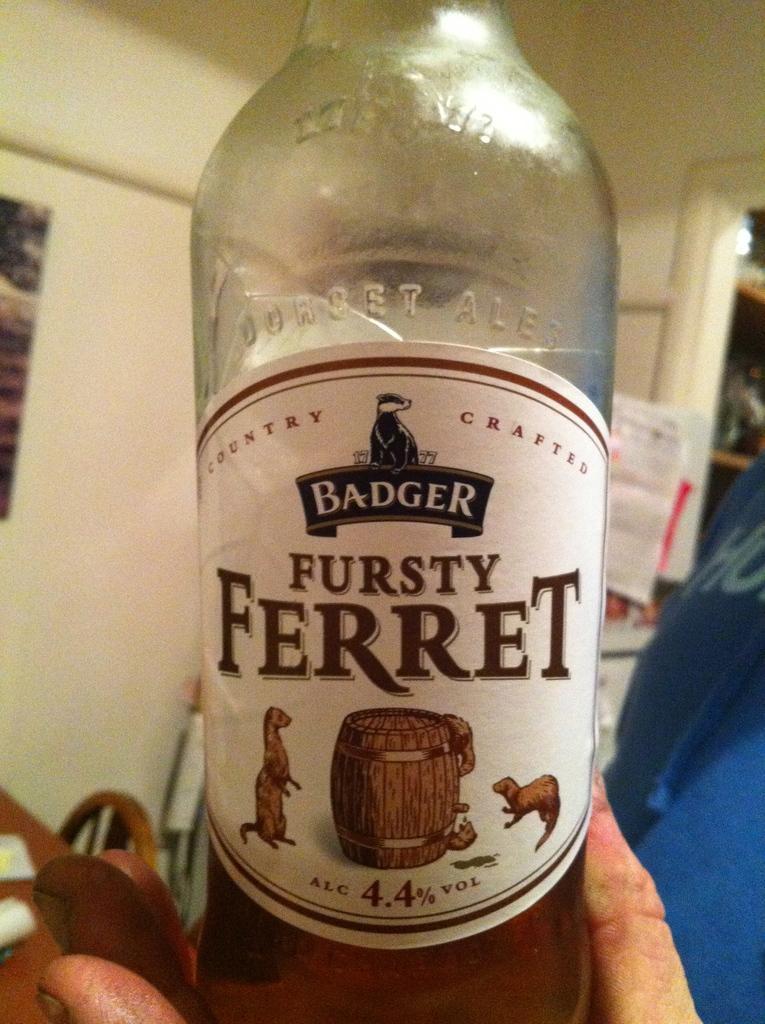Describe this image in one or two sentences. In this picture there is a bottle which is hold by a person and the word ferret is written on the bottle. 